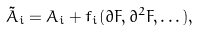Convert formula to latex. <formula><loc_0><loc_0><loc_500><loc_500>\tilde { A } _ { i } = A _ { i } + f _ { i } ( \partial F , \partial ^ { 2 } F , \dots ) ,</formula> 